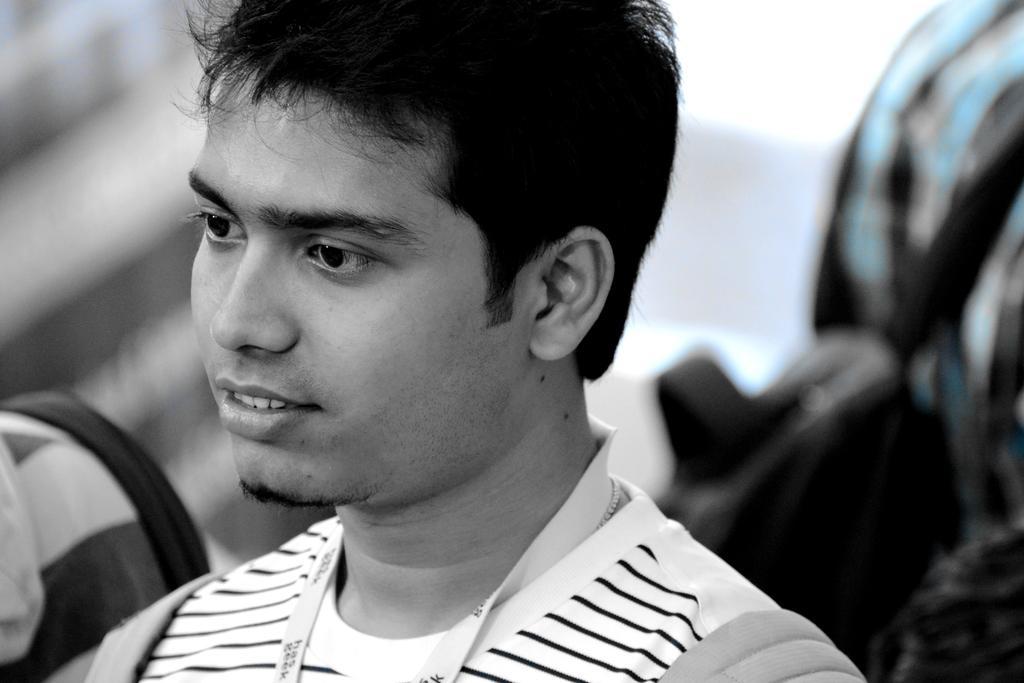Can you describe this image briefly? This is a black and white image. We can see a man and behind the man, there is the blurred background. 